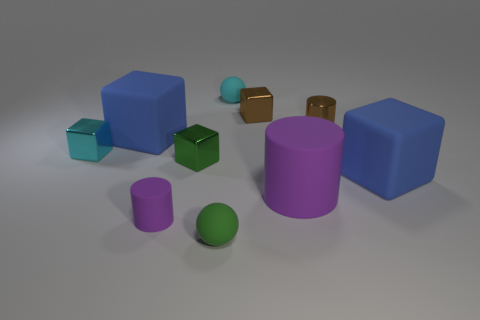Are there any large cyan cubes that have the same material as the brown cylinder?
Offer a terse response. No. Do the small brown block and the tiny green cube have the same material?
Give a very brief answer. Yes. What number of purple things are either small metal things or big spheres?
Give a very brief answer. 0. Is the number of tiny green metal blocks that are in front of the small rubber cylinder greater than the number of balls?
Ensure brevity in your answer.  No. Is there a small metallic thing of the same color as the metal cylinder?
Make the answer very short. Yes. The green rubber thing is what size?
Make the answer very short. Small. Do the small shiny cylinder and the tiny rubber cylinder have the same color?
Your answer should be compact. No. What number of things are either large green shiny objects or rubber objects in front of the tiny cyan matte ball?
Offer a very short reply. 5. How many tiny rubber balls are right of the large rubber cube right of the blue matte cube that is to the left of the brown metal block?
Provide a short and direct response. 0. What is the material of the tiny block that is the same color as the tiny metal cylinder?
Give a very brief answer. Metal. 